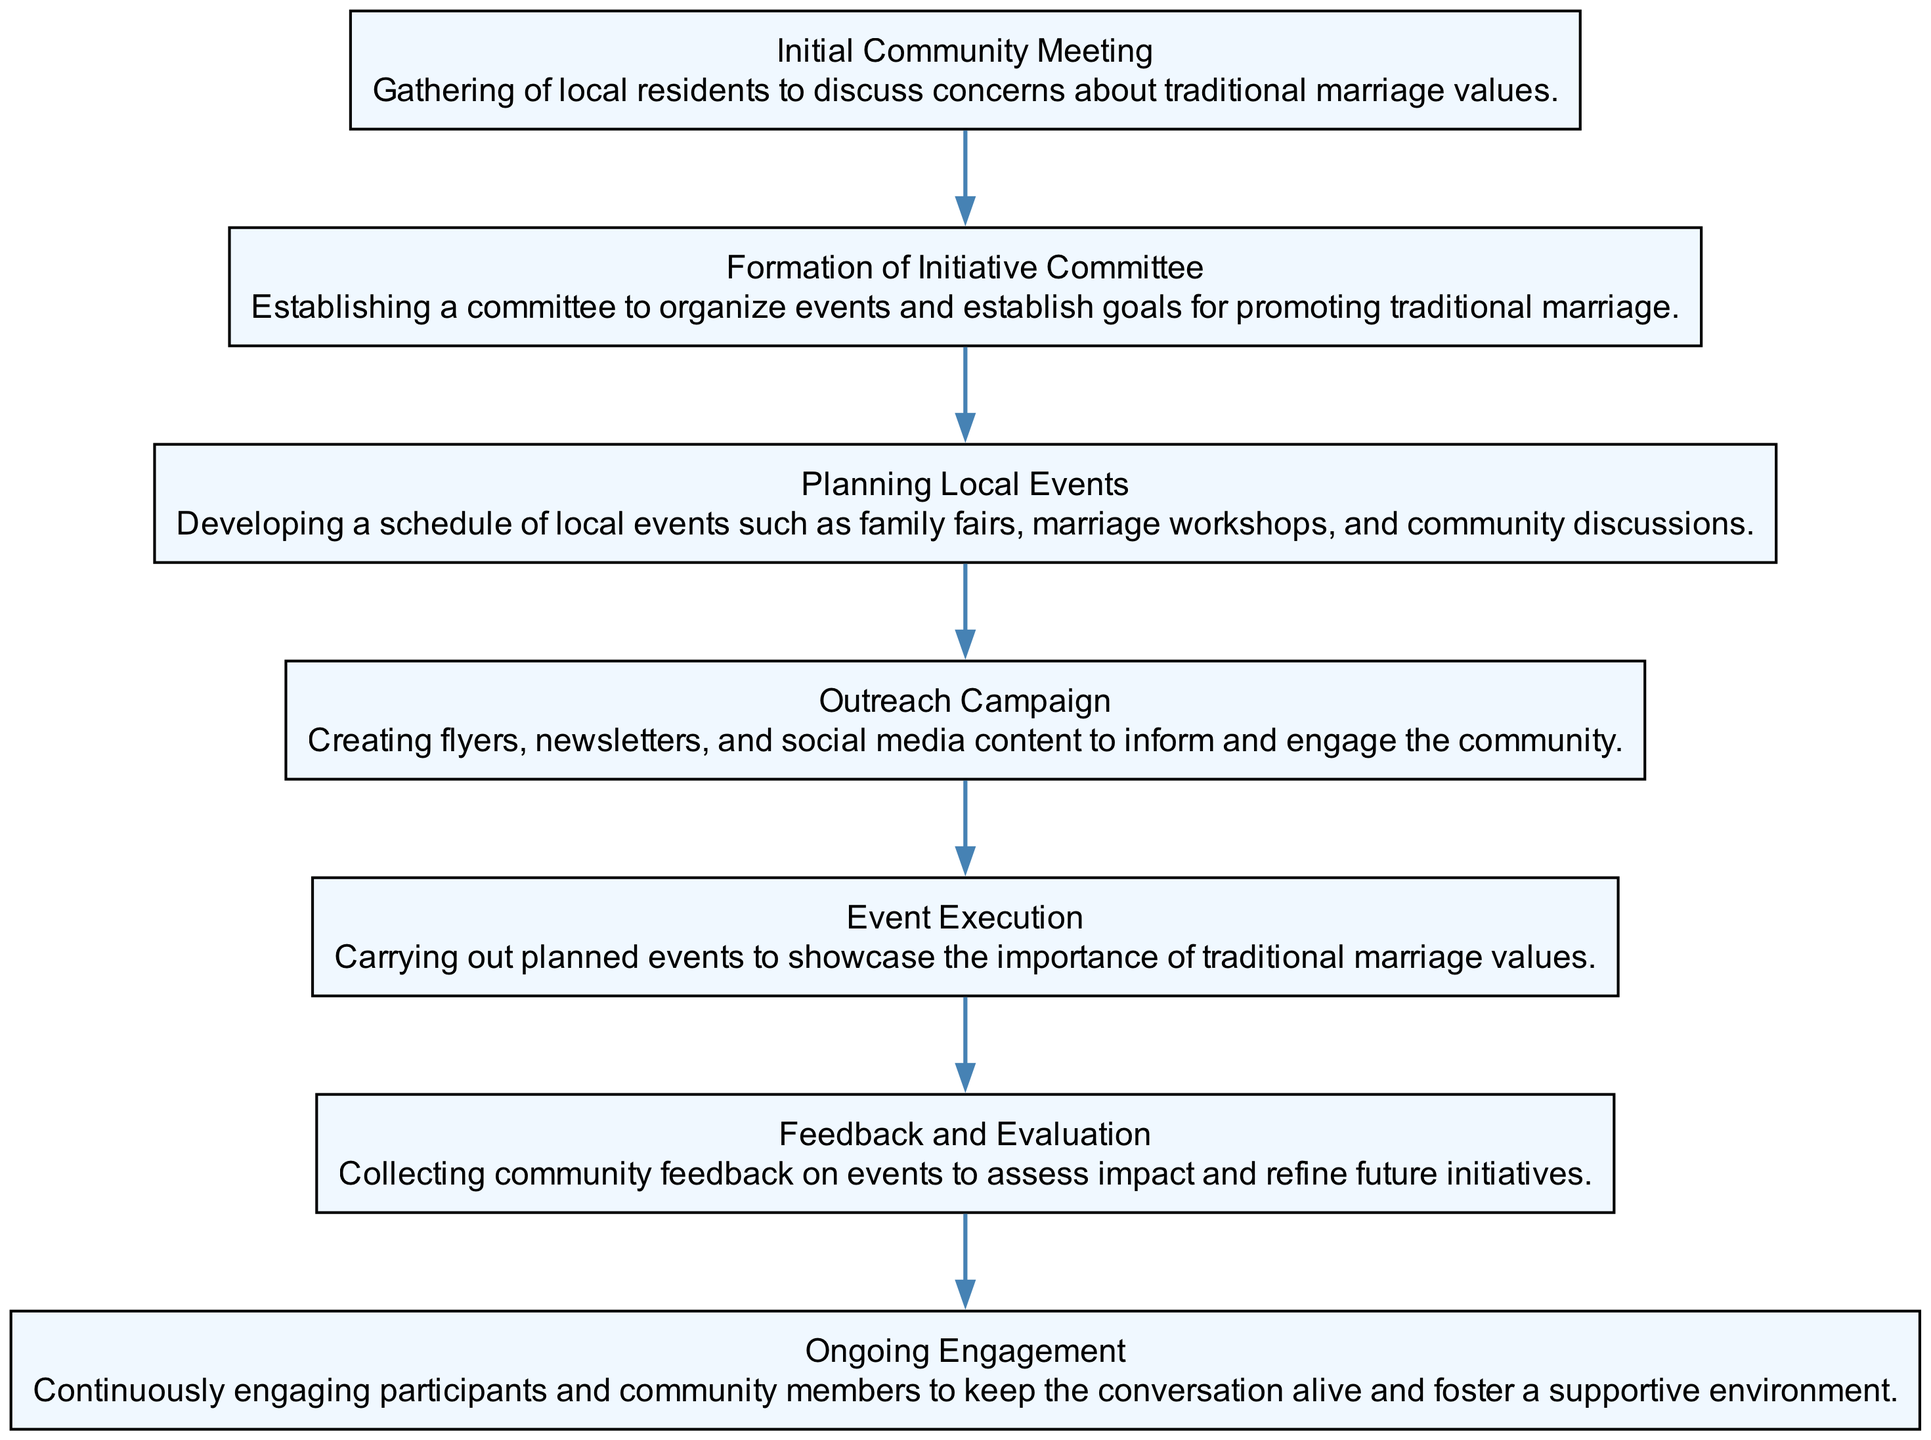What is the first step in the initiative? The first node in the flow chart is "Initial Community Meeting," indicating that the starting point of the initiative involves a gathering of local residents to discuss concerns about traditional marriage values.
Answer: Initial Community Meeting How many total steps are there in the initiative? By counting the nodes in the flow chart, there are a total of seven distinct steps outlined from the initial meeting to ongoing engagement.
Answer: 7 What does the Outreach Campaign involve? The node labeled "Outreach Campaign" describes the creation of flyers, newsletters, and social media content aimed at informing and engaging the community around traditional marriage values.
Answer: Creating flyers, newsletters, and social media content What is the purpose of the Feedback and Evaluation step? This step focuses on collecting community feedback on events to assess their impact and refine future initiatives, indicating that it plays a critical role in evaluating success.
Answer: Collecting community feedback on events What are the last two steps in the initiative flow? From the flow chart, the last two nodes are "Feedback and Evaluation" followed by "Ongoing Engagement," suggesting that the initiative emphasizes not just evaluation but also continuous community engagement.
Answer: Feedback and Evaluation, Ongoing Engagement Which step directly follows the Formation of Initiative Committee? The step immediately following "Formation of Initiative Committee" is "Planning Local Events," indicating that after forming the committee, the next action is to organize local events.
Answer: Planning Local Events What is the main goal of the Event Execution? This node is termed "Event Execution" and focuses on carrying out planned events intended to showcase the importance of traditional marriage values, underscoring its objective.
Answer: Carrying out planned events What aspect of the initiative does the Ongoing Engagement address? The "Ongoing Engagement" node centers around continuously engaging participants and community members to keep the conversation alive and foster a supportive environment for the initiative.
Answer: Continuously engaging participants and community members 